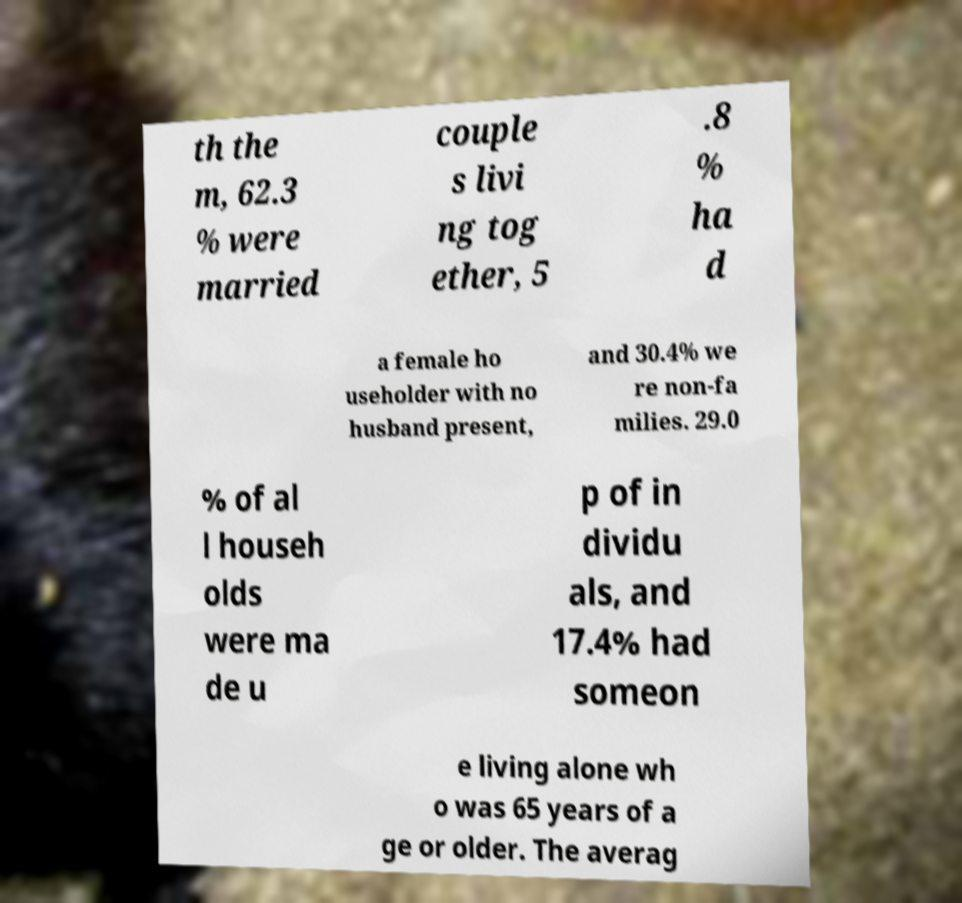Please read and relay the text visible in this image. What does it say? th the m, 62.3 % were married couple s livi ng tog ether, 5 .8 % ha d a female ho useholder with no husband present, and 30.4% we re non-fa milies. 29.0 % of al l househ olds were ma de u p of in dividu als, and 17.4% had someon e living alone wh o was 65 years of a ge or older. The averag 